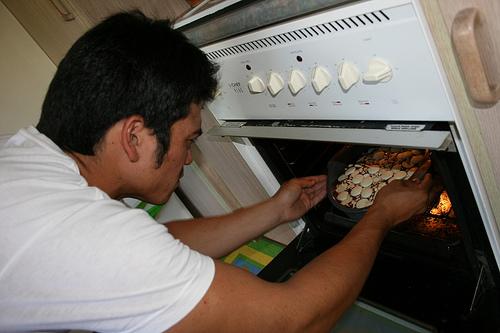Is he pulling the pan out or putting it in the oven?
Write a very short answer. Putting it in. Could the man burn himself?
Be succinct. Yes. Does this man have a mustache?
Give a very brief answer. Yes. 